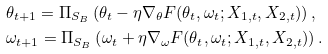<formula> <loc_0><loc_0><loc_500><loc_500>& \theta _ { t + 1 } = \Pi _ { S _ { B } } \left ( \theta _ { t } - \eta \nabla _ { \theta } F ( \theta _ { t } , \omega _ { t } ; X _ { 1 , t } , X _ { 2 , t } ) \right ) , \\ & \omega _ { t + 1 } = \Pi _ { S _ { B } } \left ( \omega _ { t } + \eta \nabla _ { \omega } F ( \theta _ { t } , \omega _ { t } ; X _ { 1 , t } , X _ { 2 , t } ) \right ) .</formula> 